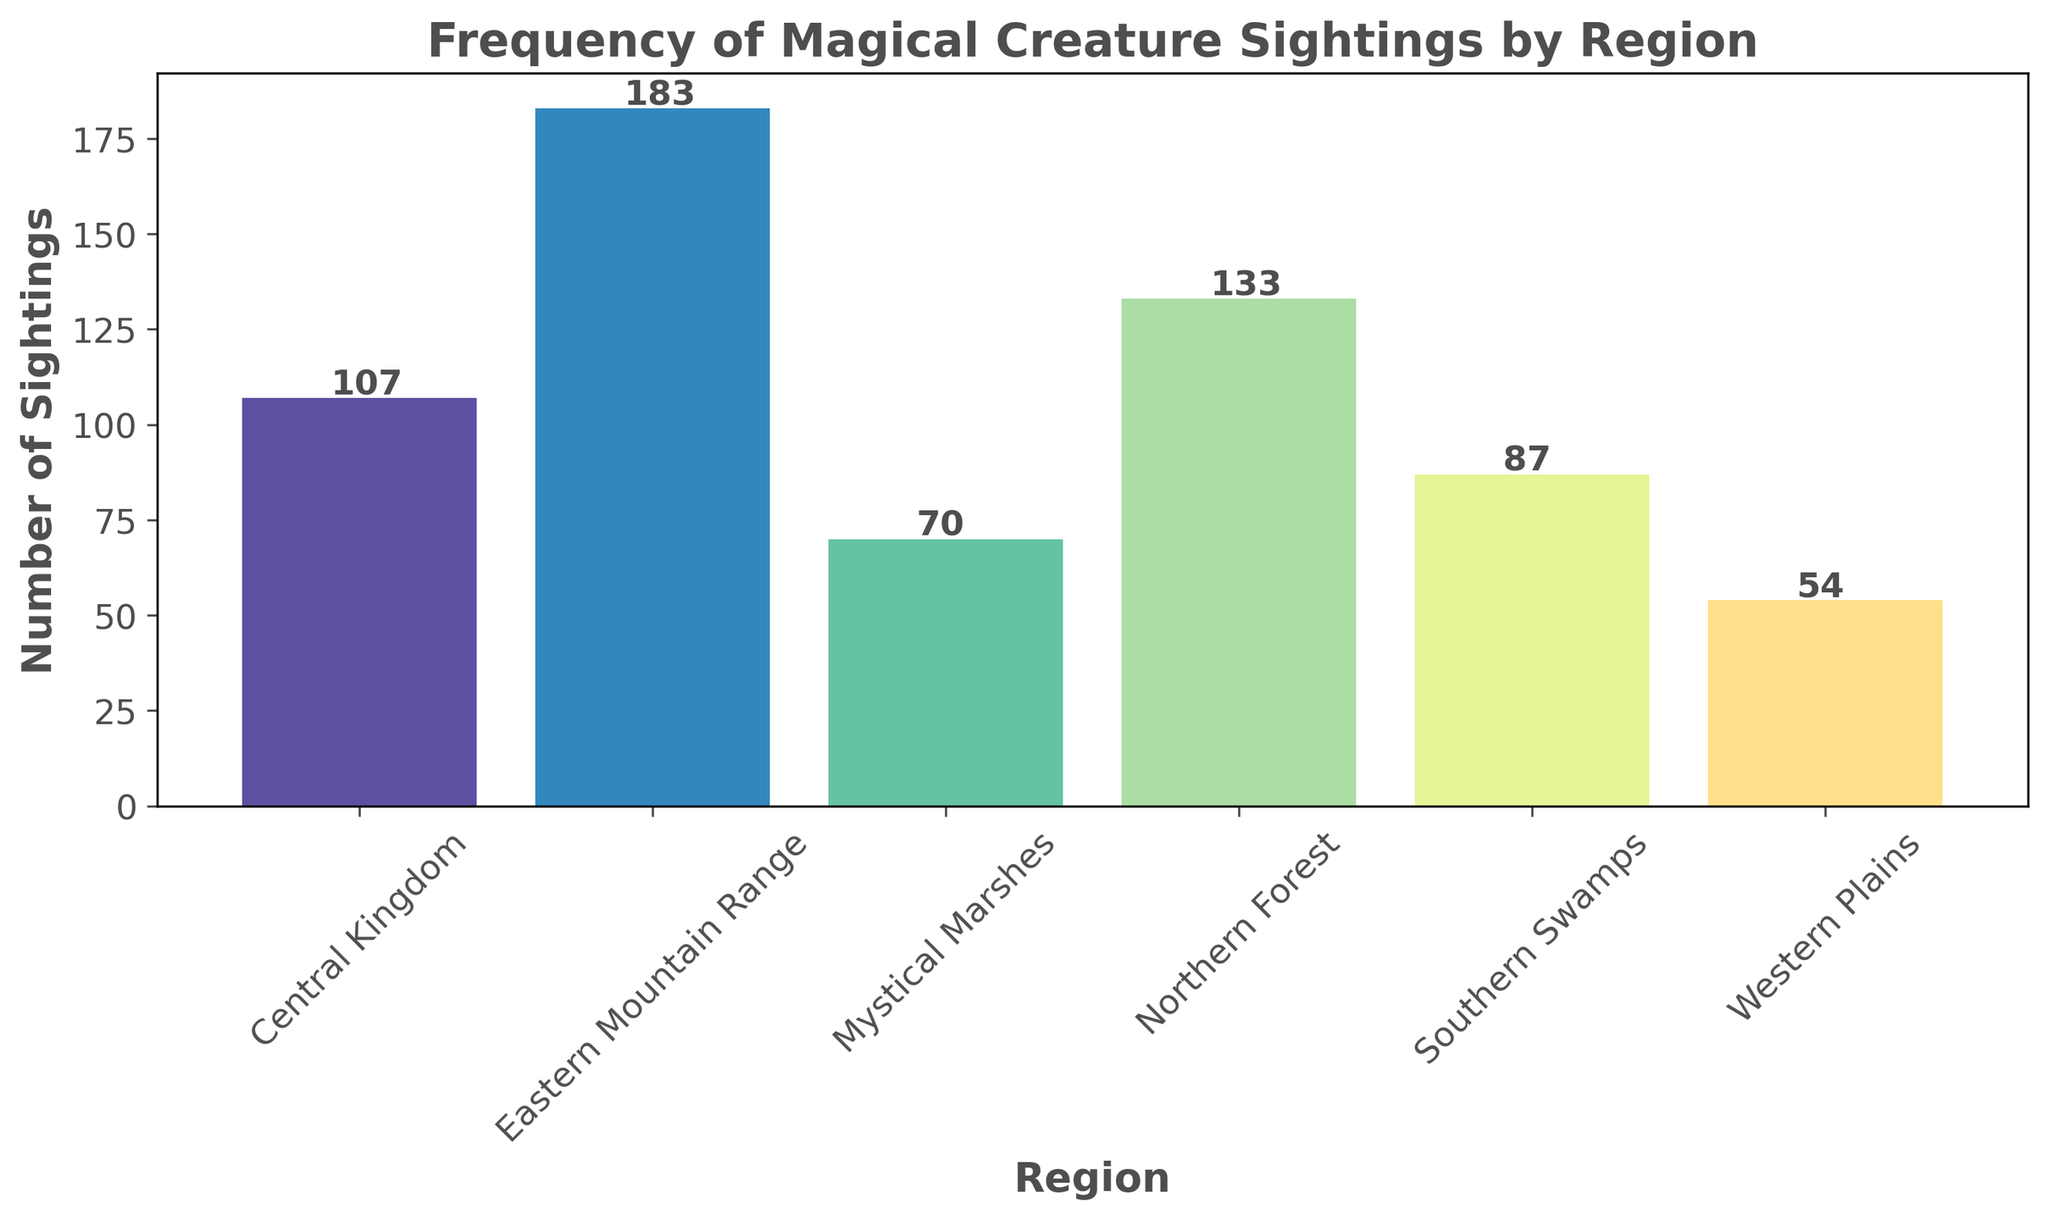Which region has the highest number of magical creature sightings? By observing the heights of the bars in the histogram, the Eastern Mountain Range has the tallest bar, indicating the highest number of sightings.
Answer: Eastern Mountain Range Which region has the lowest number of magical creature sightings? The Western Plains have the shortest bar, signifying the lowest number of sightings among all the regions.
Answer: Western Plains What is the total number of magical creature sightings in the Northern Forest and Mystical Marshes? Add the heights of the bars for the Northern Forest (34 + 30 + 36 + 33 = 133) and the Mystical Marshes (19 + 16 + 18 + 17 = 70) to get the total. Thus, the total is 133 + 70 = 203 sightings.
Answer: 203 By how much do the sightings in the Eastern Mountain Range exceed those in the Central Kingdom? Sum the number of sightings for the Eastern Mountain Range (45 + 48 + 43 + 47 = 183) and for the Central Kingdom (25 + 27 + 29 + 26 = 107). The difference is 183 - 107 = 76.
Answer: 76 Is the number of sightings in the Southern Swamps greater than in the Central Kingdom? Sum the number of sightings for the Southern Swamps (21 + 22 + 20 + 24 = 87) and the Central Kingdom (25 + 27 + 29 + 26 = 107). Comparison shows that 87 is less than 107.
Answer: No Which regions have more than 100 total sightings? Sum the sightings for each region and check which are above 100. Northern Forest: 133, Southern Swamps: 87, Eastern Mountain Range: 183, Western Plains: 54, Central Kingdom: 107, Mystical Marshes: 70. Regions with more than 100 sightings are the Northern Forest, Eastern Mountain Range, and Central Kingdom.
Answer: Northern Forest, Eastern Mountain Range, Central Kingdom What is the average number of sightings per region in the Central Kingdom? The total number of sightings in the Central Kingdom is 107. As there are 4 occasions of sightings recorded, the average is 107 / 4 = 26.75.
Answer: 26.75 Which region's bar is the second highest in the histogram? Visually comparing the bars, the second highest bar belongs to the Northern Forest.
Answer: Northern Forest If you combine the sightings from the Western Plains and Mystical Marshes, how many more sightings are there in the Eastern Mountain Range in comparison? Sum the sightings from the Western Plains (13 + 12 + 15 + 14 = 54) and Mystical Marshes (70), which total 54 + 70 = 124. The Eastern Mountain Range has 183 sightings. The difference is 183 - 124 = 59.
Answer: 59 